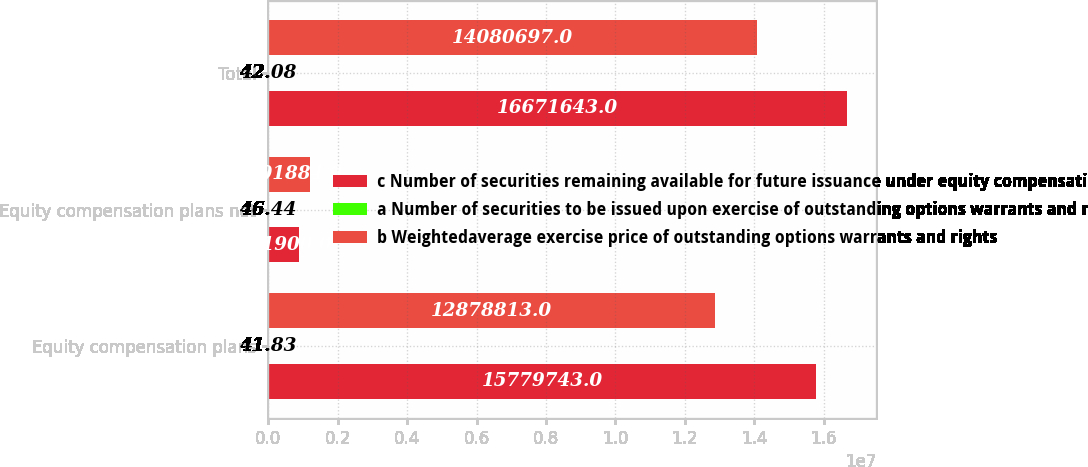<chart> <loc_0><loc_0><loc_500><loc_500><stacked_bar_chart><ecel><fcel>Equity compensation plans<fcel>Equity compensation plans not<fcel>Total<nl><fcel>c Number of securities remaining available for future issuance under equity compensation plans excluding securities reflected in column a<fcel>1.57797e+07<fcel>891900<fcel>1.66716e+07<nl><fcel>a Number of securities to be issued upon exercise of outstanding options warrants and rights<fcel>41.83<fcel>46.44<fcel>42.08<nl><fcel>b Weightedaverage exercise price of outstanding options warrants and rights<fcel>1.28788e+07<fcel>1.20188e+06<fcel>1.40807e+07<nl></chart> 